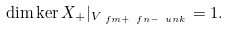<formula> <loc_0><loc_0><loc_500><loc_500>\dim \ker X _ { + } | _ { V _ { \ f m + \ f n - \ u n { k } } } = 1 .</formula> 